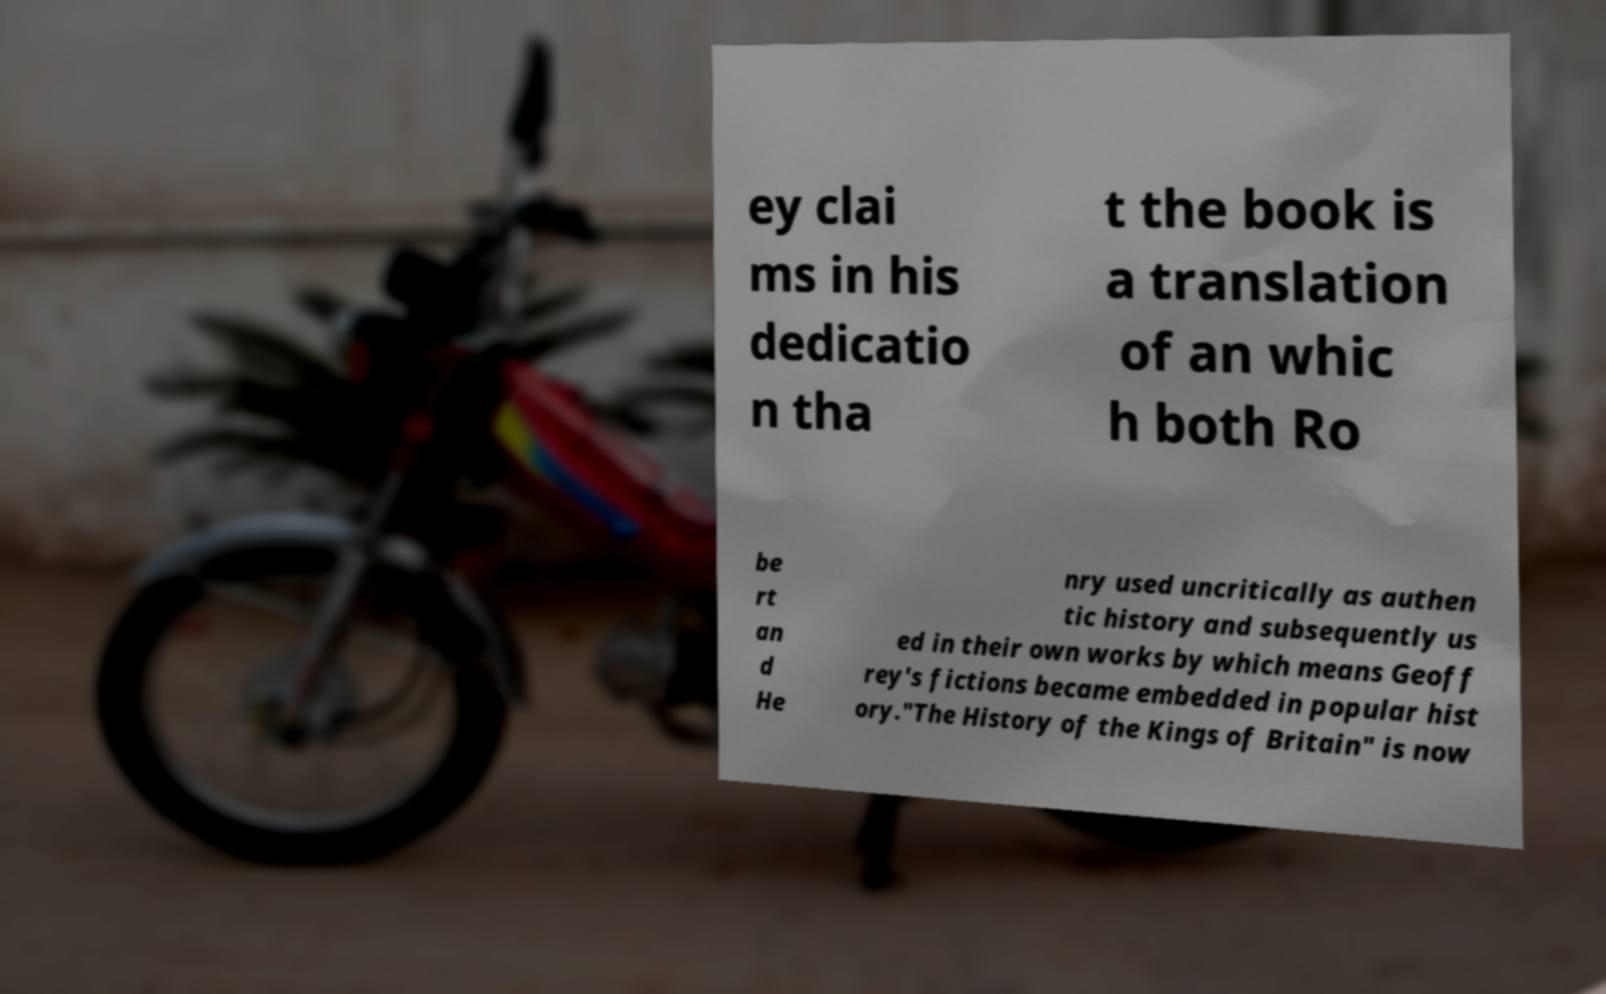Please read and relay the text visible in this image. What does it say? ey clai ms in his dedicatio n tha t the book is a translation of an whic h both Ro be rt an d He nry used uncritically as authen tic history and subsequently us ed in their own works by which means Geoff rey's fictions became embedded in popular hist ory."The History of the Kings of Britain" is now 